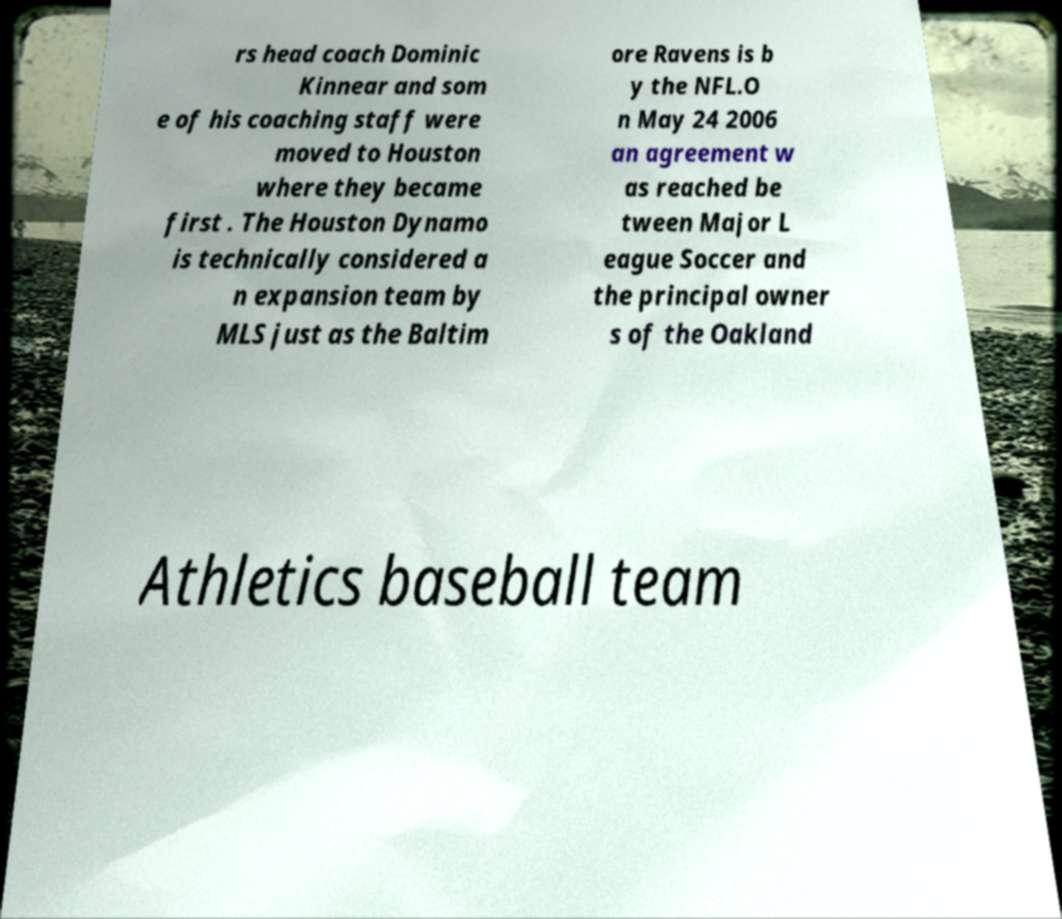Can you accurately transcribe the text from the provided image for me? rs head coach Dominic Kinnear and som e of his coaching staff were moved to Houston where they became first . The Houston Dynamo is technically considered a n expansion team by MLS just as the Baltim ore Ravens is b y the NFL.O n May 24 2006 an agreement w as reached be tween Major L eague Soccer and the principal owner s of the Oakland Athletics baseball team 